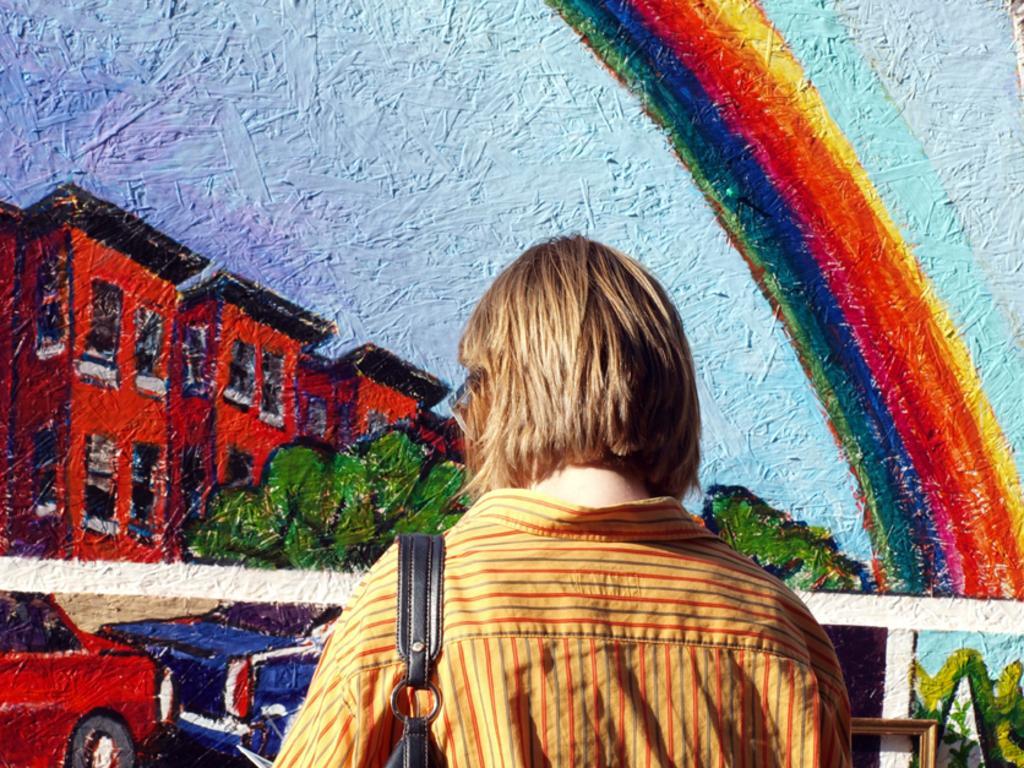Please provide a concise description of this image. In the picture we can see a wall with a painting and a person watching it wearing a handbag which is black in color. 